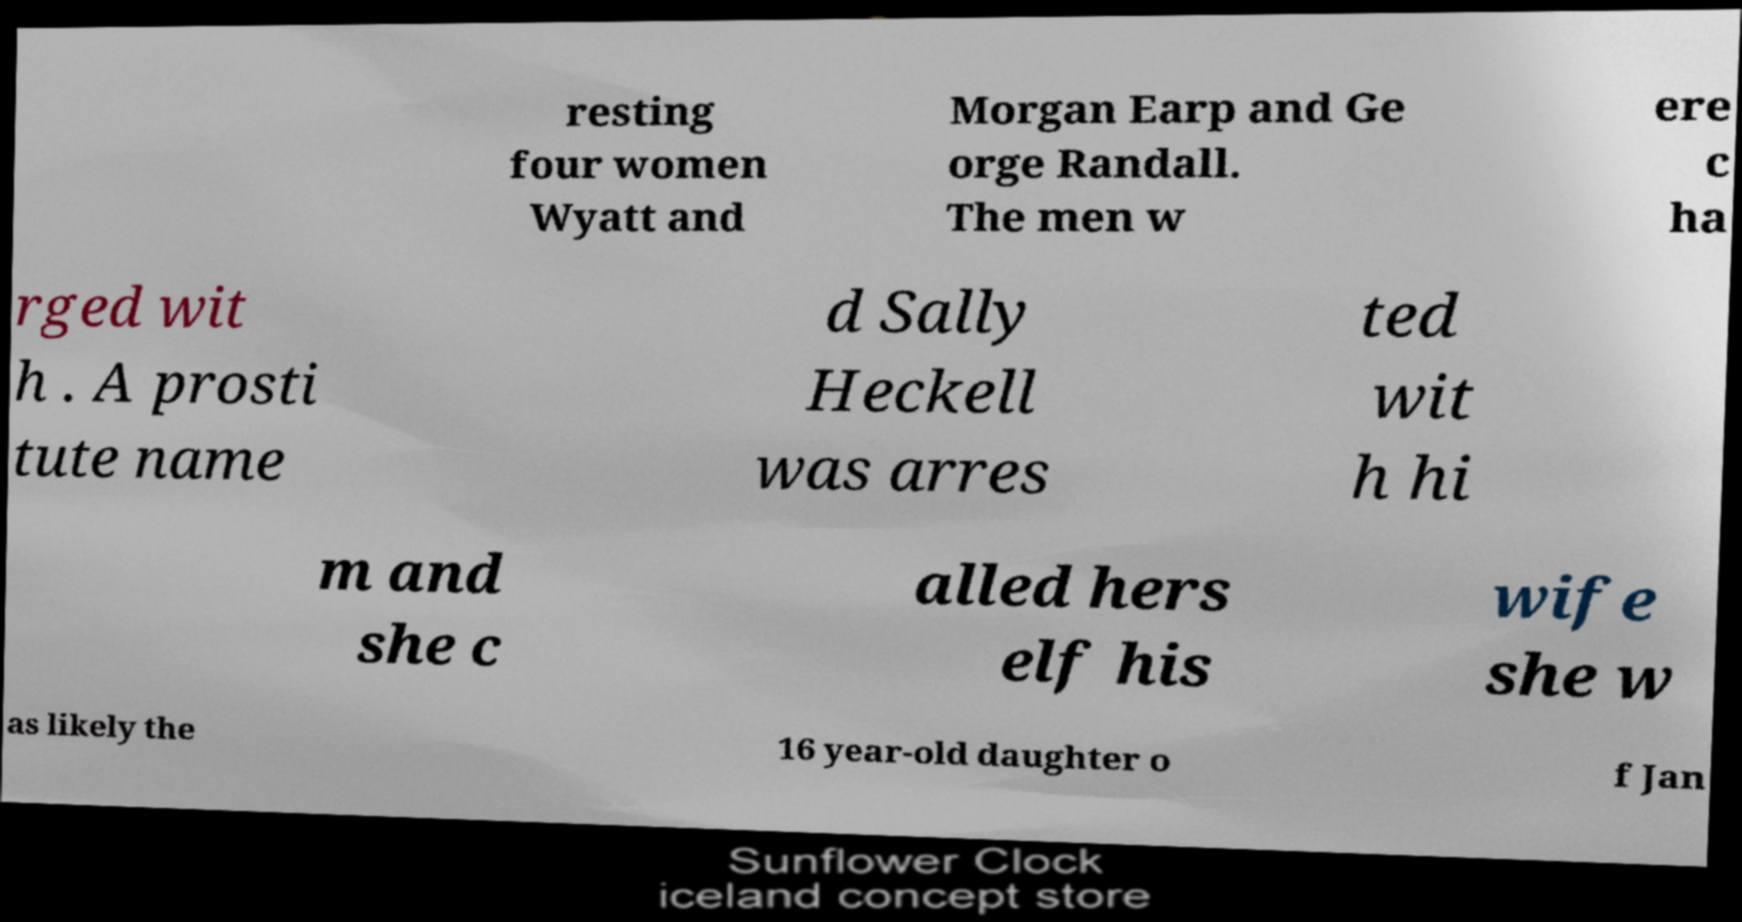Could you assist in decoding the text presented in this image and type it out clearly? resting four women Wyatt and Morgan Earp and Ge orge Randall. The men w ere c ha rged wit h . A prosti tute name d Sally Heckell was arres ted wit h hi m and she c alled hers elf his wife she w as likely the 16 year-old daughter o f Jan 